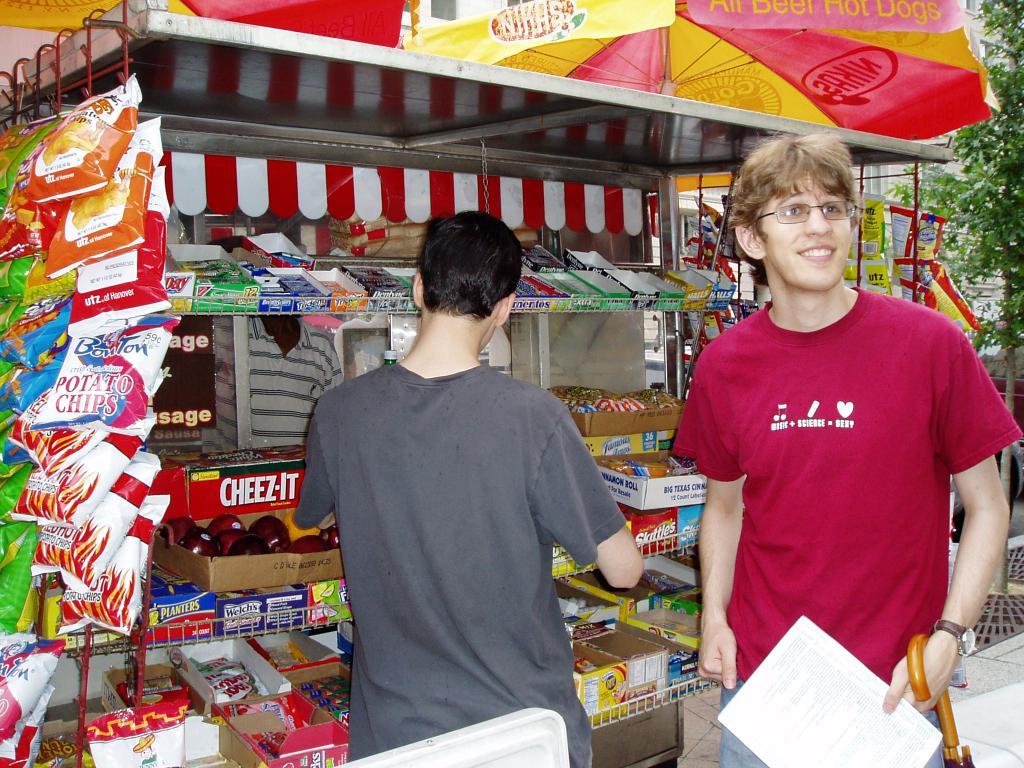What kind of thing is for sale on the left/hanging?
Provide a succinct answer. Potato chips. What is for sale on the far left in the bags?
Your answer should be very brief. Potato chips. 